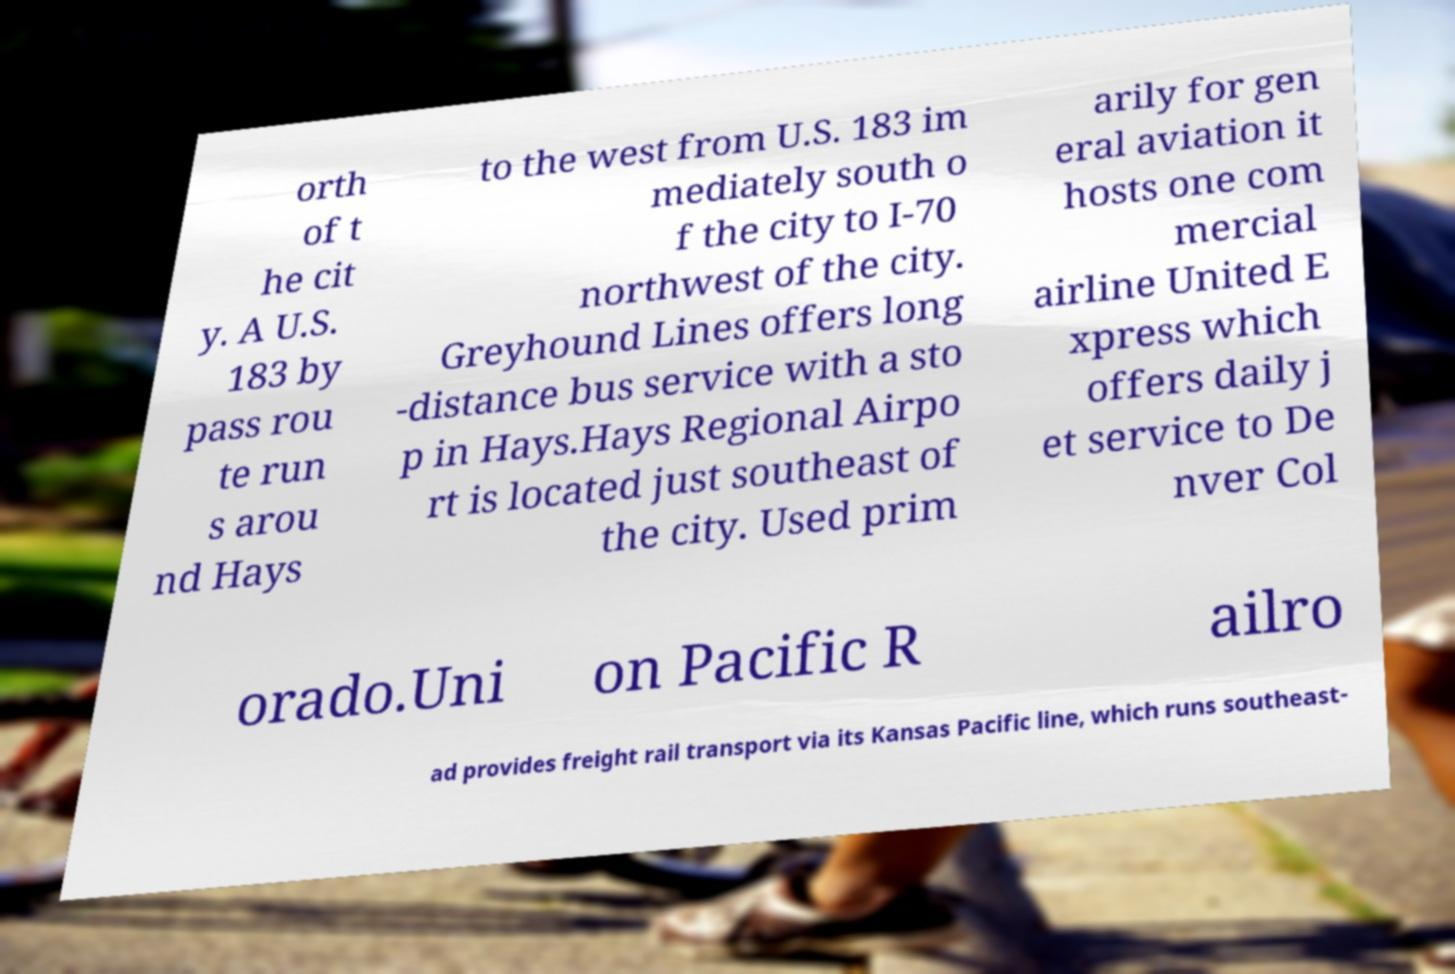Could you extract and type out the text from this image? orth of t he cit y. A U.S. 183 by pass rou te run s arou nd Hays to the west from U.S. 183 im mediately south o f the city to I-70 northwest of the city. Greyhound Lines offers long -distance bus service with a sto p in Hays.Hays Regional Airpo rt is located just southeast of the city. Used prim arily for gen eral aviation it hosts one com mercial airline United E xpress which offers daily j et service to De nver Col orado.Uni on Pacific R ailro ad provides freight rail transport via its Kansas Pacific line, which runs southeast- 